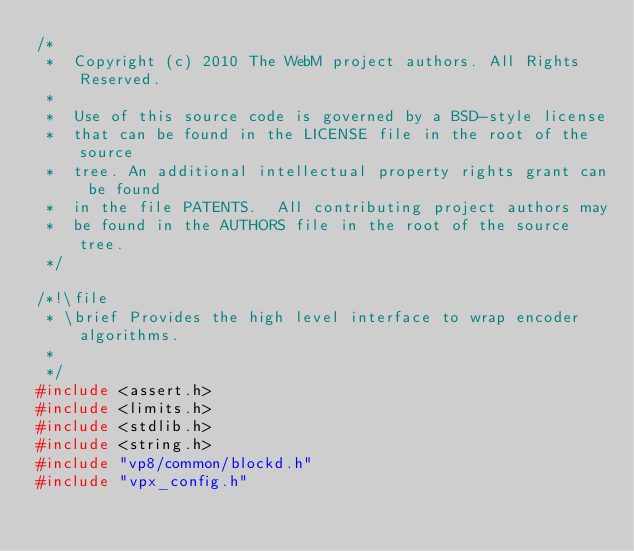Convert code to text. <code><loc_0><loc_0><loc_500><loc_500><_C_>/*
 *  Copyright (c) 2010 The WebM project authors. All Rights Reserved.
 *
 *  Use of this source code is governed by a BSD-style license
 *  that can be found in the LICENSE file in the root of the source
 *  tree. An additional intellectual property rights grant can be found
 *  in the file PATENTS.  All contributing project authors may
 *  be found in the AUTHORS file in the root of the source tree.
 */

/*!\file
 * \brief Provides the high level interface to wrap encoder algorithms.
 *
 */
#include <assert.h>
#include <limits.h>
#include <stdlib.h>
#include <string.h>
#include "vp8/common/blockd.h"
#include "vpx_config.h"</code> 